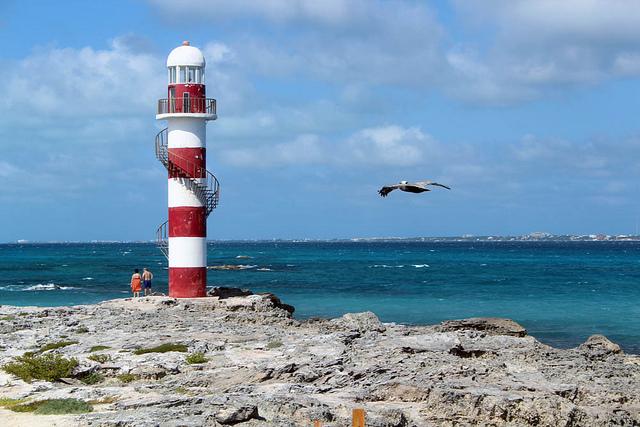Where are the stairs?
Give a very brief answer. Lighthouse. What is the red and white structure?
Answer briefly. Lighthouse. How many people are there?
Quick response, please. 2. 